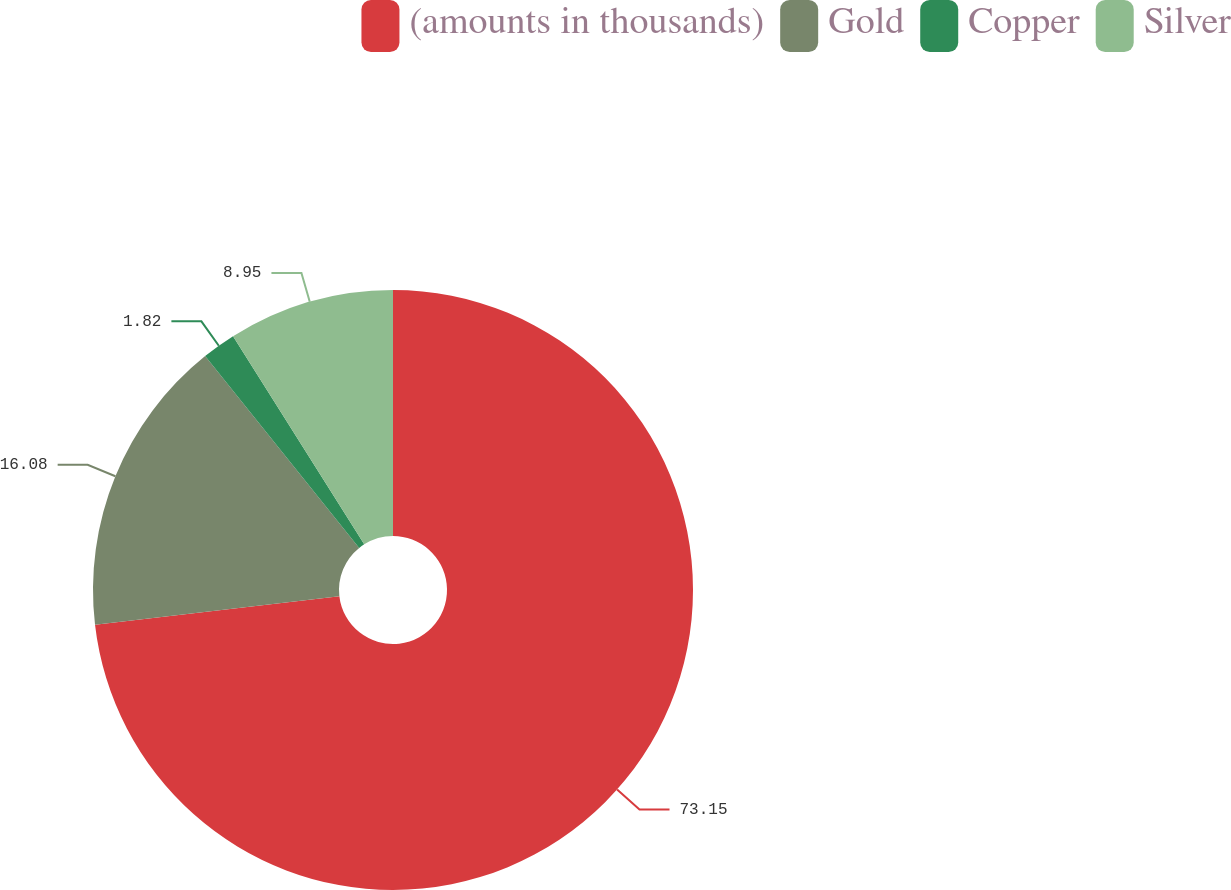Convert chart to OTSL. <chart><loc_0><loc_0><loc_500><loc_500><pie_chart><fcel>(amounts in thousands)<fcel>Gold<fcel>Copper<fcel>Silver<nl><fcel>73.15%<fcel>16.08%<fcel>1.82%<fcel>8.95%<nl></chart> 